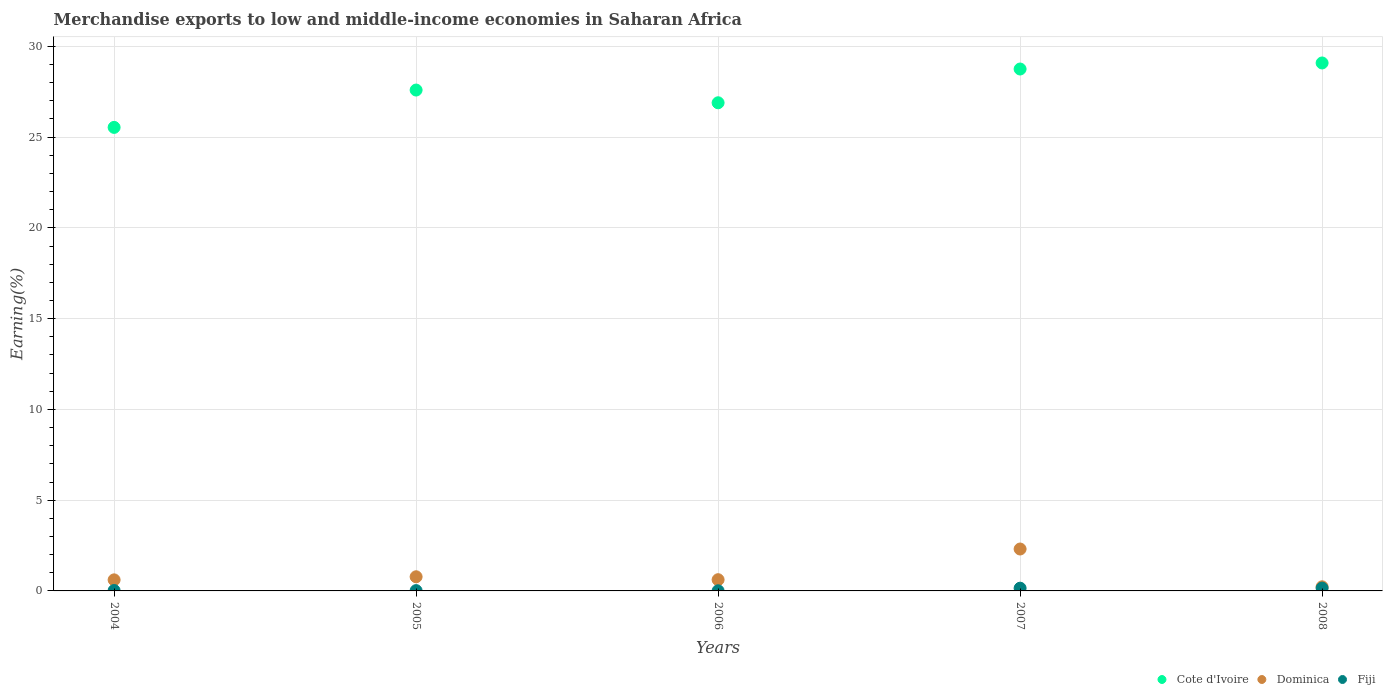How many different coloured dotlines are there?
Offer a terse response. 3. Is the number of dotlines equal to the number of legend labels?
Your response must be concise. Yes. What is the percentage of amount earned from merchandise exports in Cote d'Ivoire in 2004?
Give a very brief answer. 25.54. Across all years, what is the maximum percentage of amount earned from merchandise exports in Dominica?
Your answer should be very brief. 2.31. Across all years, what is the minimum percentage of amount earned from merchandise exports in Cote d'Ivoire?
Your answer should be very brief. 25.54. In which year was the percentage of amount earned from merchandise exports in Dominica maximum?
Offer a terse response. 2007. In which year was the percentage of amount earned from merchandise exports in Cote d'Ivoire minimum?
Provide a short and direct response. 2004. What is the total percentage of amount earned from merchandise exports in Dominica in the graph?
Ensure brevity in your answer.  4.54. What is the difference between the percentage of amount earned from merchandise exports in Cote d'Ivoire in 2007 and that in 2008?
Give a very brief answer. -0.33. What is the difference between the percentage of amount earned from merchandise exports in Fiji in 2004 and the percentage of amount earned from merchandise exports in Cote d'Ivoire in 2007?
Your answer should be compact. -28.73. What is the average percentage of amount earned from merchandise exports in Cote d'Ivoire per year?
Ensure brevity in your answer.  27.57. In the year 2006, what is the difference between the percentage of amount earned from merchandise exports in Dominica and percentage of amount earned from merchandise exports in Cote d'Ivoire?
Offer a very short reply. -26.27. In how many years, is the percentage of amount earned from merchandise exports in Dominica greater than 26 %?
Offer a terse response. 0. What is the ratio of the percentage of amount earned from merchandise exports in Dominica in 2005 to that in 2008?
Make the answer very short. 3.44. Is the percentage of amount earned from merchandise exports in Cote d'Ivoire in 2007 less than that in 2008?
Your response must be concise. Yes. What is the difference between the highest and the second highest percentage of amount earned from merchandise exports in Cote d'Ivoire?
Give a very brief answer. 0.33. What is the difference between the highest and the lowest percentage of amount earned from merchandise exports in Fiji?
Your answer should be very brief. 0.15. In how many years, is the percentage of amount earned from merchandise exports in Fiji greater than the average percentage of amount earned from merchandise exports in Fiji taken over all years?
Your answer should be compact. 2. Is the sum of the percentage of amount earned from merchandise exports in Cote d'Ivoire in 2005 and 2006 greater than the maximum percentage of amount earned from merchandise exports in Fiji across all years?
Provide a succinct answer. Yes. Is it the case that in every year, the sum of the percentage of amount earned from merchandise exports in Dominica and percentage of amount earned from merchandise exports in Fiji  is greater than the percentage of amount earned from merchandise exports in Cote d'Ivoire?
Your answer should be very brief. No. Is the percentage of amount earned from merchandise exports in Cote d'Ivoire strictly greater than the percentage of amount earned from merchandise exports in Dominica over the years?
Provide a succinct answer. Yes. How many years are there in the graph?
Provide a succinct answer. 5. What is the difference between two consecutive major ticks on the Y-axis?
Give a very brief answer. 5. Are the values on the major ticks of Y-axis written in scientific E-notation?
Ensure brevity in your answer.  No. Does the graph contain any zero values?
Offer a terse response. No. Does the graph contain grids?
Provide a short and direct response. Yes. Where does the legend appear in the graph?
Provide a short and direct response. Bottom right. How many legend labels are there?
Provide a succinct answer. 3. What is the title of the graph?
Offer a very short reply. Merchandise exports to low and middle-income economies in Saharan Africa. What is the label or title of the X-axis?
Your response must be concise. Years. What is the label or title of the Y-axis?
Ensure brevity in your answer.  Earning(%). What is the Earning(%) of Cote d'Ivoire in 2004?
Offer a terse response. 25.54. What is the Earning(%) in Dominica in 2004?
Provide a succinct answer. 0.61. What is the Earning(%) of Fiji in 2004?
Give a very brief answer. 0.02. What is the Earning(%) of Cote d'Ivoire in 2005?
Your answer should be compact. 27.59. What is the Earning(%) of Dominica in 2005?
Your answer should be compact. 0.78. What is the Earning(%) in Fiji in 2005?
Your answer should be very brief. 0.02. What is the Earning(%) in Cote d'Ivoire in 2006?
Give a very brief answer. 26.89. What is the Earning(%) in Dominica in 2006?
Keep it short and to the point. 0.62. What is the Earning(%) in Fiji in 2006?
Offer a terse response. 0.01. What is the Earning(%) of Cote d'Ivoire in 2007?
Your response must be concise. 28.75. What is the Earning(%) in Dominica in 2007?
Offer a very short reply. 2.31. What is the Earning(%) in Fiji in 2007?
Your response must be concise. 0.15. What is the Earning(%) in Cote d'Ivoire in 2008?
Keep it short and to the point. 29.09. What is the Earning(%) in Dominica in 2008?
Ensure brevity in your answer.  0.23. What is the Earning(%) of Fiji in 2008?
Your answer should be compact. 0.16. Across all years, what is the maximum Earning(%) in Cote d'Ivoire?
Your response must be concise. 29.09. Across all years, what is the maximum Earning(%) in Dominica?
Ensure brevity in your answer.  2.31. Across all years, what is the maximum Earning(%) in Fiji?
Give a very brief answer. 0.16. Across all years, what is the minimum Earning(%) in Cote d'Ivoire?
Your answer should be compact. 25.54. Across all years, what is the minimum Earning(%) of Dominica?
Offer a very short reply. 0.23. Across all years, what is the minimum Earning(%) in Fiji?
Give a very brief answer. 0.01. What is the total Earning(%) of Cote d'Ivoire in the graph?
Provide a short and direct response. 137.86. What is the total Earning(%) of Dominica in the graph?
Make the answer very short. 4.54. What is the total Earning(%) in Fiji in the graph?
Provide a short and direct response. 0.35. What is the difference between the Earning(%) in Cote d'Ivoire in 2004 and that in 2005?
Provide a succinct answer. -2.06. What is the difference between the Earning(%) in Dominica in 2004 and that in 2005?
Your answer should be very brief. -0.17. What is the difference between the Earning(%) of Fiji in 2004 and that in 2005?
Make the answer very short. 0.01. What is the difference between the Earning(%) of Cote d'Ivoire in 2004 and that in 2006?
Your answer should be very brief. -1.36. What is the difference between the Earning(%) of Dominica in 2004 and that in 2006?
Give a very brief answer. -0.01. What is the difference between the Earning(%) of Fiji in 2004 and that in 2006?
Offer a very short reply. 0.01. What is the difference between the Earning(%) of Cote d'Ivoire in 2004 and that in 2007?
Offer a terse response. -3.22. What is the difference between the Earning(%) of Dominica in 2004 and that in 2007?
Give a very brief answer. -1.7. What is the difference between the Earning(%) of Fiji in 2004 and that in 2007?
Make the answer very short. -0.13. What is the difference between the Earning(%) in Cote d'Ivoire in 2004 and that in 2008?
Provide a short and direct response. -3.55. What is the difference between the Earning(%) of Dominica in 2004 and that in 2008?
Give a very brief answer. 0.38. What is the difference between the Earning(%) in Fiji in 2004 and that in 2008?
Give a very brief answer. -0.13. What is the difference between the Earning(%) in Cote d'Ivoire in 2005 and that in 2006?
Your response must be concise. 0.7. What is the difference between the Earning(%) of Dominica in 2005 and that in 2006?
Your response must be concise. 0.16. What is the difference between the Earning(%) of Fiji in 2005 and that in 2006?
Make the answer very short. 0.01. What is the difference between the Earning(%) of Cote d'Ivoire in 2005 and that in 2007?
Give a very brief answer. -1.16. What is the difference between the Earning(%) of Dominica in 2005 and that in 2007?
Make the answer very short. -1.53. What is the difference between the Earning(%) in Fiji in 2005 and that in 2007?
Make the answer very short. -0.13. What is the difference between the Earning(%) in Cote d'Ivoire in 2005 and that in 2008?
Provide a succinct answer. -1.49. What is the difference between the Earning(%) in Dominica in 2005 and that in 2008?
Your answer should be compact. 0.55. What is the difference between the Earning(%) of Fiji in 2005 and that in 2008?
Your response must be concise. -0.14. What is the difference between the Earning(%) in Cote d'Ivoire in 2006 and that in 2007?
Your response must be concise. -1.86. What is the difference between the Earning(%) in Dominica in 2006 and that in 2007?
Make the answer very short. -1.69. What is the difference between the Earning(%) of Fiji in 2006 and that in 2007?
Your answer should be compact. -0.14. What is the difference between the Earning(%) in Cote d'Ivoire in 2006 and that in 2008?
Ensure brevity in your answer.  -2.19. What is the difference between the Earning(%) in Dominica in 2006 and that in 2008?
Offer a terse response. 0.39. What is the difference between the Earning(%) in Fiji in 2006 and that in 2008?
Provide a succinct answer. -0.15. What is the difference between the Earning(%) of Cote d'Ivoire in 2007 and that in 2008?
Keep it short and to the point. -0.33. What is the difference between the Earning(%) in Dominica in 2007 and that in 2008?
Your response must be concise. 2.08. What is the difference between the Earning(%) of Fiji in 2007 and that in 2008?
Ensure brevity in your answer.  -0. What is the difference between the Earning(%) in Cote d'Ivoire in 2004 and the Earning(%) in Dominica in 2005?
Your response must be concise. 24.76. What is the difference between the Earning(%) of Cote d'Ivoire in 2004 and the Earning(%) of Fiji in 2005?
Your answer should be very brief. 25.52. What is the difference between the Earning(%) in Dominica in 2004 and the Earning(%) in Fiji in 2005?
Provide a succinct answer. 0.59. What is the difference between the Earning(%) in Cote d'Ivoire in 2004 and the Earning(%) in Dominica in 2006?
Ensure brevity in your answer.  24.92. What is the difference between the Earning(%) of Cote d'Ivoire in 2004 and the Earning(%) of Fiji in 2006?
Your answer should be compact. 25.53. What is the difference between the Earning(%) of Dominica in 2004 and the Earning(%) of Fiji in 2006?
Ensure brevity in your answer.  0.6. What is the difference between the Earning(%) in Cote d'Ivoire in 2004 and the Earning(%) in Dominica in 2007?
Your answer should be compact. 23.23. What is the difference between the Earning(%) in Cote d'Ivoire in 2004 and the Earning(%) in Fiji in 2007?
Keep it short and to the point. 25.39. What is the difference between the Earning(%) of Dominica in 2004 and the Earning(%) of Fiji in 2007?
Your answer should be very brief. 0.46. What is the difference between the Earning(%) in Cote d'Ivoire in 2004 and the Earning(%) in Dominica in 2008?
Your response must be concise. 25.31. What is the difference between the Earning(%) of Cote d'Ivoire in 2004 and the Earning(%) of Fiji in 2008?
Keep it short and to the point. 25.38. What is the difference between the Earning(%) in Dominica in 2004 and the Earning(%) in Fiji in 2008?
Offer a terse response. 0.45. What is the difference between the Earning(%) of Cote d'Ivoire in 2005 and the Earning(%) of Dominica in 2006?
Ensure brevity in your answer.  26.98. What is the difference between the Earning(%) of Cote d'Ivoire in 2005 and the Earning(%) of Fiji in 2006?
Your answer should be very brief. 27.59. What is the difference between the Earning(%) in Dominica in 2005 and the Earning(%) in Fiji in 2006?
Provide a short and direct response. 0.77. What is the difference between the Earning(%) in Cote d'Ivoire in 2005 and the Earning(%) in Dominica in 2007?
Keep it short and to the point. 25.29. What is the difference between the Earning(%) in Cote d'Ivoire in 2005 and the Earning(%) in Fiji in 2007?
Make the answer very short. 27.44. What is the difference between the Earning(%) of Dominica in 2005 and the Earning(%) of Fiji in 2007?
Your response must be concise. 0.63. What is the difference between the Earning(%) of Cote d'Ivoire in 2005 and the Earning(%) of Dominica in 2008?
Provide a short and direct response. 27.37. What is the difference between the Earning(%) in Cote d'Ivoire in 2005 and the Earning(%) in Fiji in 2008?
Keep it short and to the point. 27.44. What is the difference between the Earning(%) of Dominica in 2005 and the Earning(%) of Fiji in 2008?
Your response must be concise. 0.62. What is the difference between the Earning(%) of Cote d'Ivoire in 2006 and the Earning(%) of Dominica in 2007?
Keep it short and to the point. 24.58. What is the difference between the Earning(%) of Cote d'Ivoire in 2006 and the Earning(%) of Fiji in 2007?
Ensure brevity in your answer.  26.74. What is the difference between the Earning(%) of Dominica in 2006 and the Earning(%) of Fiji in 2007?
Your answer should be compact. 0.47. What is the difference between the Earning(%) of Cote d'Ivoire in 2006 and the Earning(%) of Dominica in 2008?
Ensure brevity in your answer.  26.67. What is the difference between the Earning(%) in Cote d'Ivoire in 2006 and the Earning(%) in Fiji in 2008?
Your answer should be compact. 26.74. What is the difference between the Earning(%) of Dominica in 2006 and the Earning(%) of Fiji in 2008?
Keep it short and to the point. 0.46. What is the difference between the Earning(%) in Cote d'Ivoire in 2007 and the Earning(%) in Dominica in 2008?
Give a very brief answer. 28.53. What is the difference between the Earning(%) in Cote d'Ivoire in 2007 and the Earning(%) in Fiji in 2008?
Your answer should be very brief. 28.6. What is the difference between the Earning(%) in Dominica in 2007 and the Earning(%) in Fiji in 2008?
Offer a terse response. 2.15. What is the average Earning(%) in Cote d'Ivoire per year?
Give a very brief answer. 27.57. What is the average Earning(%) of Dominica per year?
Ensure brevity in your answer.  0.91. What is the average Earning(%) of Fiji per year?
Your response must be concise. 0.07. In the year 2004, what is the difference between the Earning(%) of Cote d'Ivoire and Earning(%) of Dominica?
Your answer should be compact. 24.93. In the year 2004, what is the difference between the Earning(%) of Cote d'Ivoire and Earning(%) of Fiji?
Provide a succinct answer. 25.51. In the year 2004, what is the difference between the Earning(%) of Dominica and Earning(%) of Fiji?
Offer a terse response. 0.59. In the year 2005, what is the difference between the Earning(%) of Cote d'Ivoire and Earning(%) of Dominica?
Provide a short and direct response. 26.81. In the year 2005, what is the difference between the Earning(%) in Cote d'Ivoire and Earning(%) in Fiji?
Ensure brevity in your answer.  27.58. In the year 2005, what is the difference between the Earning(%) of Dominica and Earning(%) of Fiji?
Offer a terse response. 0.76. In the year 2006, what is the difference between the Earning(%) in Cote d'Ivoire and Earning(%) in Dominica?
Your response must be concise. 26.27. In the year 2006, what is the difference between the Earning(%) in Cote d'Ivoire and Earning(%) in Fiji?
Your answer should be very brief. 26.89. In the year 2006, what is the difference between the Earning(%) in Dominica and Earning(%) in Fiji?
Your response must be concise. 0.61. In the year 2007, what is the difference between the Earning(%) in Cote d'Ivoire and Earning(%) in Dominica?
Offer a terse response. 26.44. In the year 2007, what is the difference between the Earning(%) in Cote d'Ivoire and Earning(%) in Fiji?
Make the answer very short. 28.6. In the year 2007, what is the difference between the Earning(%) of Dominica and Earning(%) of Fiji?
Your response must be concise. 2.16. In the year 2008, what is the difference between the Earning(%) of Cote d'Ivoire and Earning(%) of Dominica?
Give a very brief answer. 28.86. In the year 2008, what is the difference between the Earning(%) in Cote d'Ivoire and Earning(%) in Fiji?
Give a very brief answer. 28.93. In the year 2008, what is the difference between the Earning(%) of Dominica and Earning(%) of Fiji?
Offer a very short reply. 0.07. What is the ratio of the Earning(%) of Cote d'Ivoire in 2004 to that in 2005?
Your response must be concise. 0.93. What is the ratio of the Earning(%) of Dominica in 2004 to that in 2005?
Give a very brief answer. 0.78. What is the ratio of the Earning(%) of Fiji in 2004 to that in 2005?
Offer a terse response. 1.33. What is the ratio of the Earning(%) in Cote d'Ivoire in 2004 to that in 2006?
Offer a terse response. 0.95. What is the ratio of the Earning(%) in Fiji in 2004 to that in 2006?
Your response must be concise. 3.03. What is the ratio of the Earning(%) in Cote d'Ivoire in 2004 to that in 2007?
Provide a short and direct response. 0.89. What is the ratio of the Earning(%) in Dominica in 2004 to that in 2007?
Make the answer very short. 0.26. What is the ratio of the Earning(%) in Fiji in 2004 to that in 2007?
Your answer should be very brief. 0.15. What is the ratio of the Earning(%) in Cote d'Ivoire in 2004 to that in 2008?
Offer a very short reply. 0.88. What is the ratio of the Earning(%) in Dominica in 2004 to that in 2008?
Offer a very short reply. 2.69. What is the ratio of the Earning(%) in Fiji in 2004 to that in 2008?
Give a very brief answer. 0.14. What is the ratio of the Earning(%) of Cote d'Ivoire in 2005 to that in 2006?
Your response must be concise. 1.03. What is the ratio of the Earning(%) of Dominica in 2005 to that in 2006?
Keep it short and to the point. 1.26. What is the ratio of the Earning(%) in Fiji in 2005 to that in 2006?
Provide a succinct answer. 2.28. What is the ratio of the Earning(%) in Cote d'Ivoire in 2005 to that in 2007?
Provide a succinct answer. 0.96. What is the ratio of the Earning(%) in Dominica in 2005 to that in 2007?
Provide a short and direct response. 0.34. What is the ratio of the Earning(%) of Fiji in 2005 to that in 2007?
Ensure brevity in your answer.  0.11. What is the ratio of the Earning(%) of Cote d'Ivoire in 2005 to that in 2008?
Your answer should be compact. 0.95. What is the ratio of the Earning(%) of Dominica in 2005 to that in 2008?
Your answer should be compact. 3.44. What is the ratio of the Earning(%) in Fiji in 2005 to that in 2008?
Offer a terse response. 0.11. What is the ratio of the Earning(%) in Cote d'Ivoire in 2006 to that in 2007?
Your answer should be very brief. 0.94. What is the ratio of the Earning(%) in Dominica in 2006 to that in 2007?
Your answer should be compact. 0.27. What is the ratio of the Earning(%) of Fiji in 2006 to that in 2007?
Your answer should be compact. 0.05. What is the ratio of the Earning(%) in Cote d'Ivoire in 2006 to that in 2008?
Your answer should be very brief. 0.92. What is the ratio of the Earning(%) in Dominica in 2006 to that in 2008?
Provide a succinct answer. 2.73. What is the ratio of the Earning(%) of Fiji in 2006 to that in 2008?
Provide a short and direct response. 0.05. What is the ratio of the Earning(%) in Cote d'Ivoire in 2007 to that in 2008?
Give a very brief answer. 0.99. What is the ratio of the Earning(%) of Dominica in 2007 to that in 2008?
Keep it short and to the point. 10.19. What is the ratio of the Earning(%) in Fiji in 2007 to that in 2008?
Your answer should be compact. 0.97. What is the difference between the highest and the second highest Earning(%) of Cote d'Ivoire?
Make the answer very short. 0.33. What is the difference between the highest and the second highest Earning(%) of Dominica?
Offer a very short reply. 1.53. What is the difference between the highest and the second highest Earning(%) of Fiji?
Offer a terse response. 0. What is the difference between the highest and the lowest Earning(%) of Cote d'Ivoire?
Make the answer very short. 3.55. What is the difference between the highest and the lowest Earning(%) of Dominica?
Offer a terse response. 2.08. What is the difference between the highest and the lowest Earning(%) in Fiji?
Offer a terse response. 0.15. 